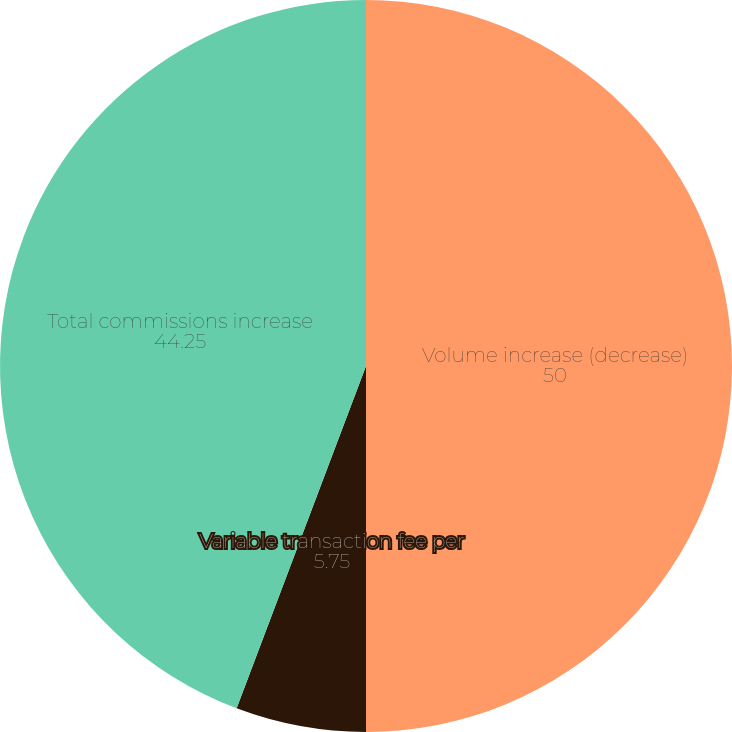Convert chart. <chart><loc_0><loc_0><loc_500><loc_500><pie_chart><fcel>Volume increase (decrease)<fcel>Variable transaction fee per<fcel>Total commissions increase<nl><fcel>50.0%<fcel>5.75%<fcel>44.25%<nl></chart> 